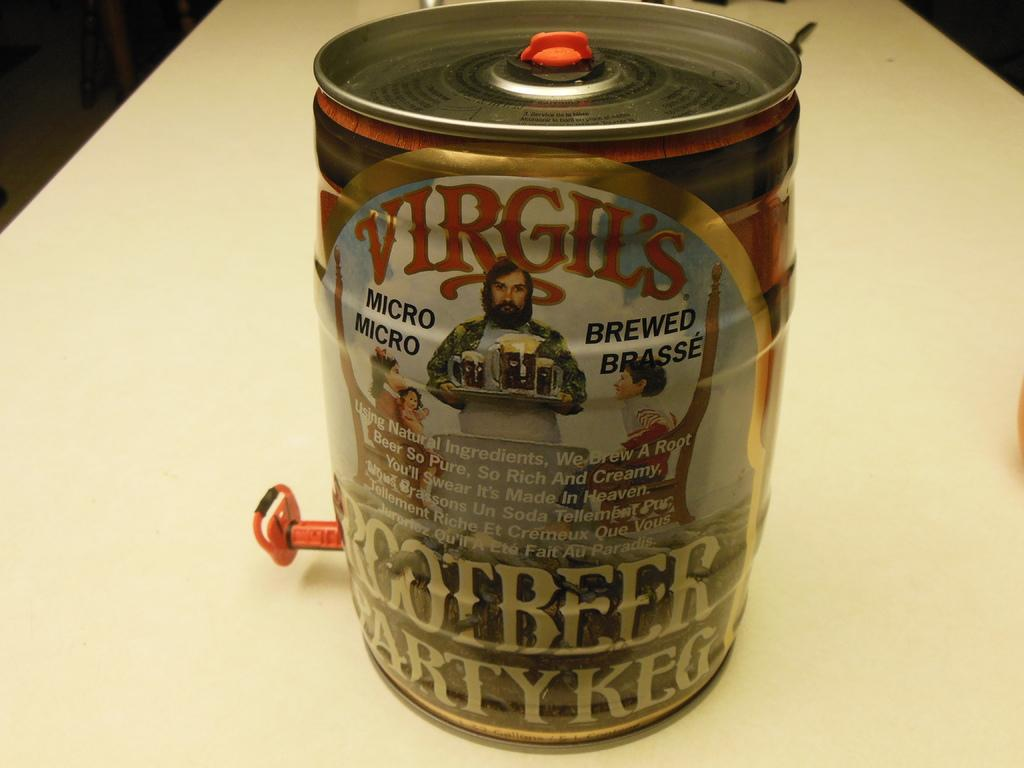<image>
Offer a succinct explanation of the picture presented. A party keg filled with Virgil's Rootbeer is sitting on a countertop. 